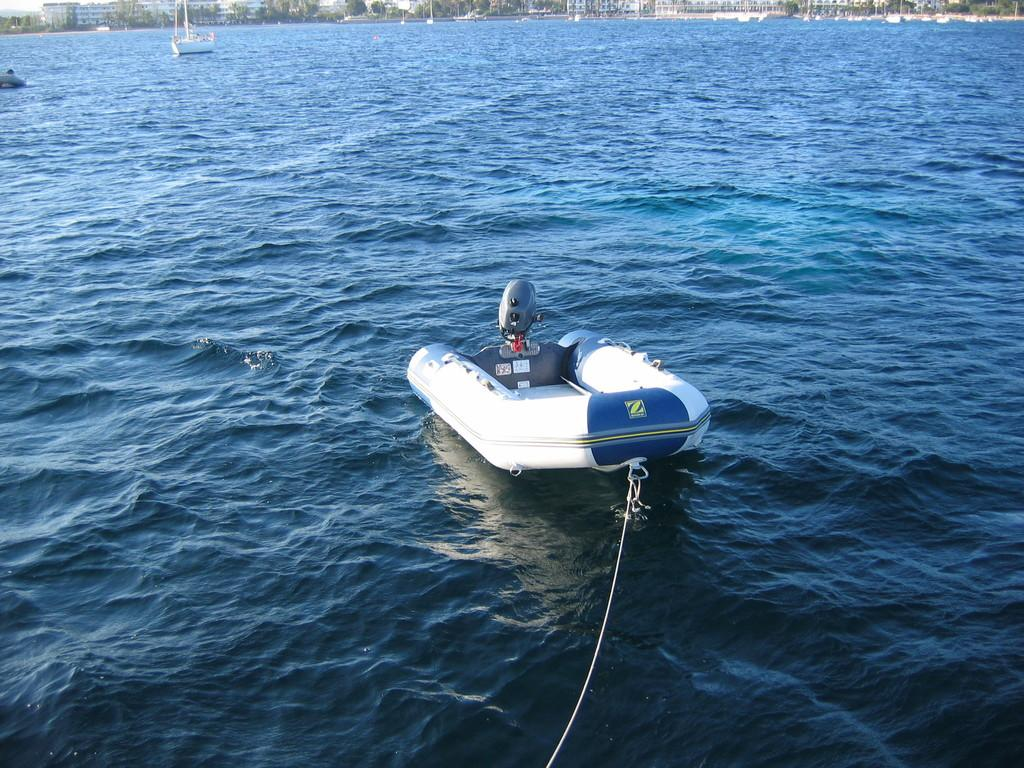Provide a one-sentence caption for the provided image. A Zodiac inflateable boat with an outboard motor and no one on it. 